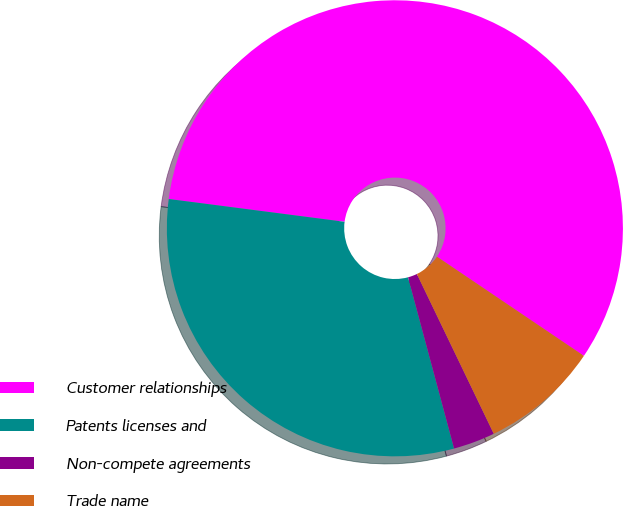Convert chart to OTSL. <chart><loc_0><loc_0><loc_500><loc_500><pie_chart><fcel>Customer relationships<fcel>Patents licenses and<fcel>Non-compete agreements<fcel>Trade name<nl><fcel>57.4%<fcel>31.23%<fcel>2.96%<fcel>8.41%<nl></chart> 